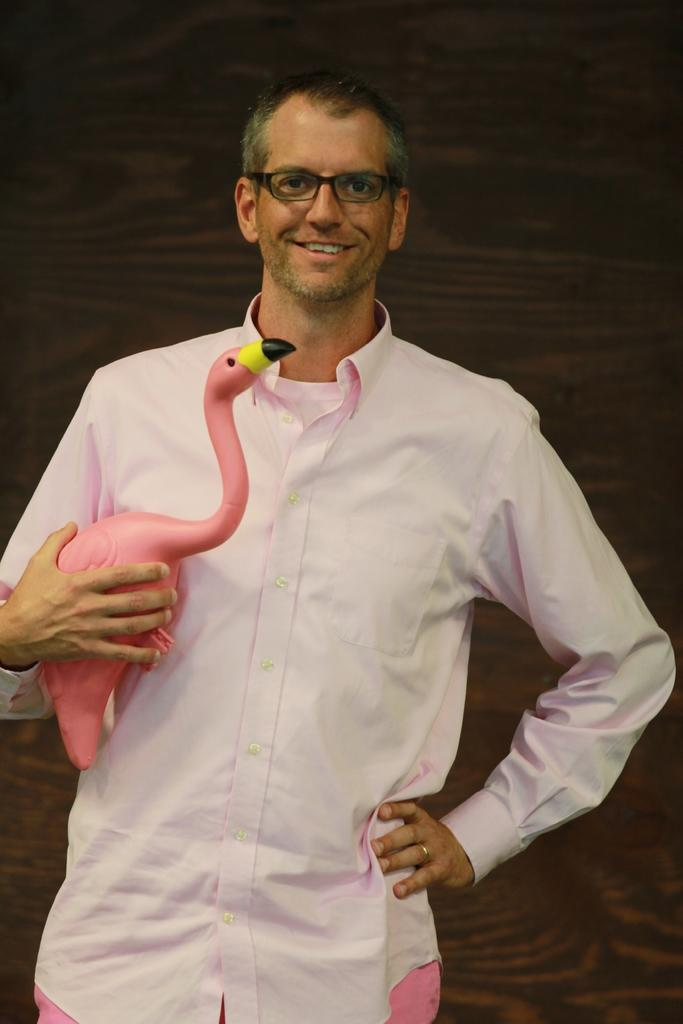What is the man in the image holding? The man is holding a toy in the image. What can be seen on the man's face? The man has spectacles and is smiling in the image. What is the color of the background in the image? The background of the image is dark. What type of furniture is visible in the image? There is no furniture present in the image; it features a man holding a toy and smiling against a dark background. 